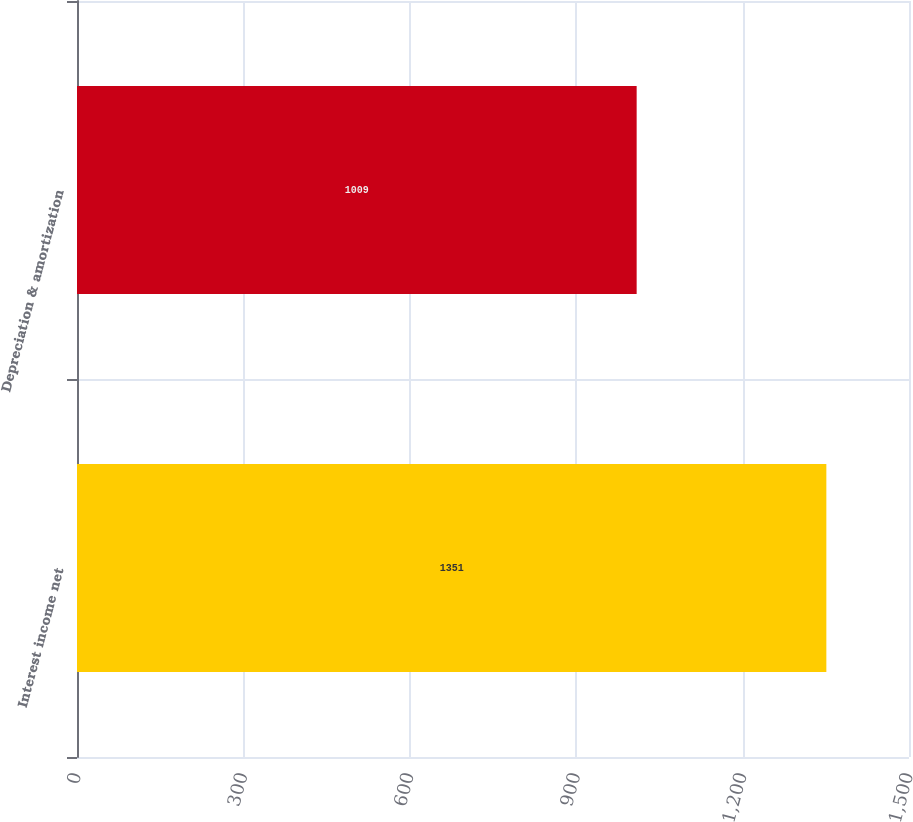Convert chart. <chart><loc_0><loc_0><loc_500><loc_500><bar_chart><fcel>Interest income net<fcel>Depreciation & amortization<nl><fcel>1351<fcel>1009<nl></chart> 